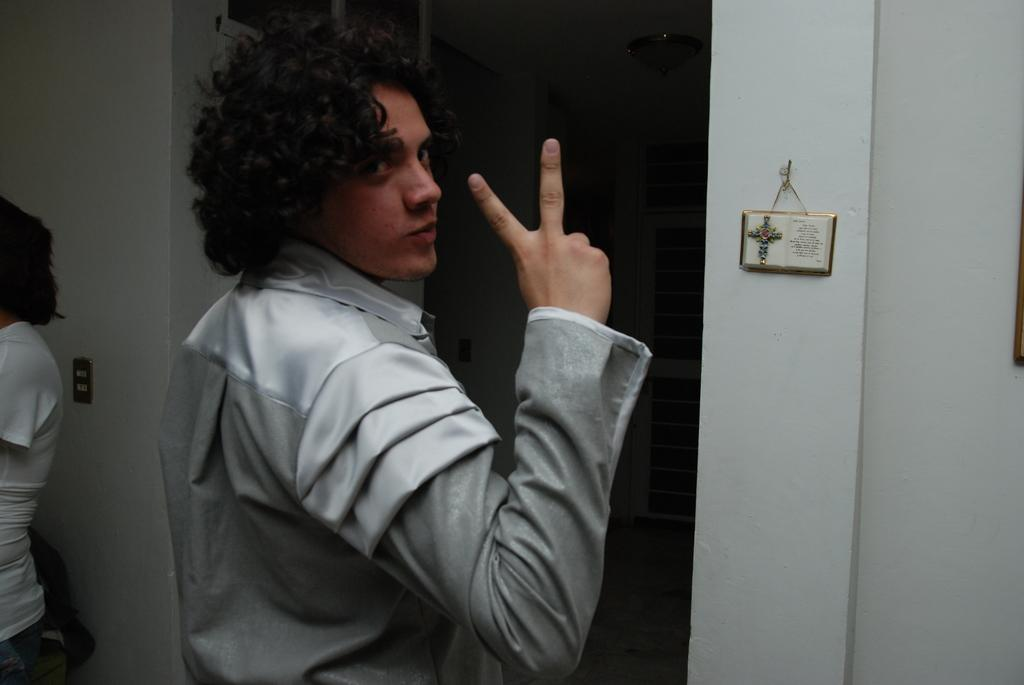What is the man in the image doing? There is a man standing in the image. What can be seen on the backside of the man? There is a switchboard on the backside of the man. What is present on the wall in the image? There is a photo frame with a picture and text on a wall. Who else is present in the image? There is a woman standing in the image. How many rabbits are hopping around in the image? There are no rabbits present in the image. What type of pest is visible in the image? There is no pest visible in the image. 